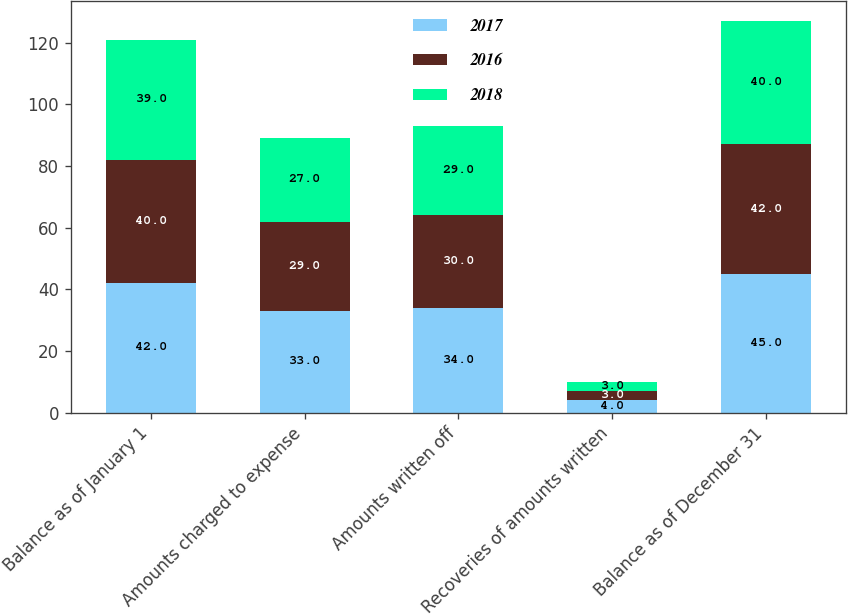Convert chart to OTSL. <chart><loc_0><loc_0><loc_500><loc_500><stacked_bar_chart><ecel><fcel>Balance as of January 1<fcel>Amounts charged to expense<fcel>Amounts written off<fcel>Recoveries of amounts written<fcel>Balance as of December 31<nl><fcel>2017<fcel>42<fcel>33<fcel>34<fcel>4<fcel>45<nl><fcel>2016<fcel>40<fcel>29<fcel>30<fcel>3<fcel>42<nl><fcel>2018<fcel>39<fcel>27<fcel>29<fcel>3<fcel>40<nl></chart> 